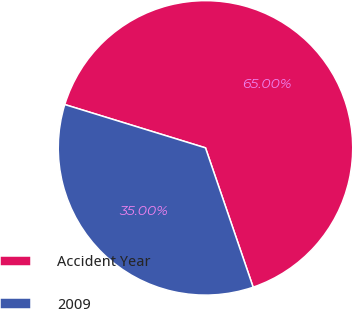Convert chart to OTSL. <chart><loc_0><loc_0><loc_500><loc_500><pie_chart><fcel>Accident Year<fcel>2009<nl><fcel>65.0%<fcel>35.0%<nl></chart> 